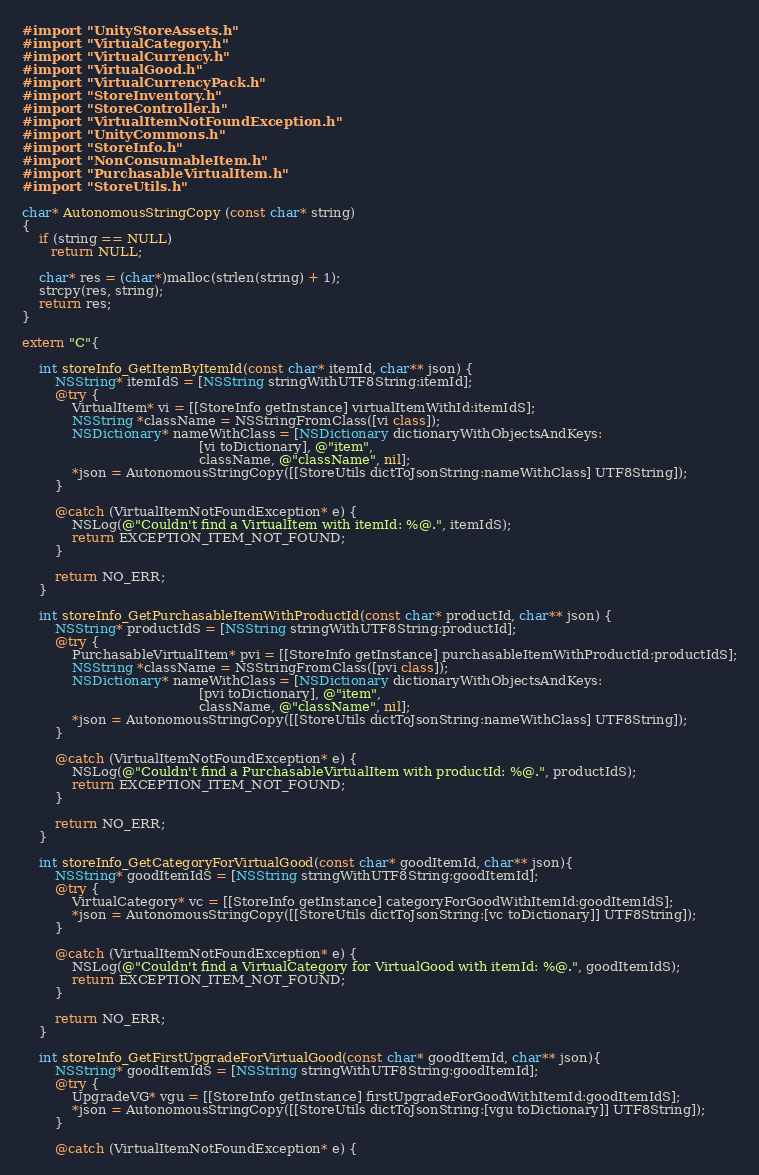<code> <loc_0><loc_0><loc_500><loc_500><_ObjectiveC_>#import "UnityStoreAssets.h"
#import "VirtualCategory.h"
#import "VirtualCurrency.h"
#import "VirtualGood.h"
#import "VirtualCurrencyPack.h"
#import "StoreInventory.h"
#import "StoreController.h"
#import "VirtualItemNotFoundException.h"
#import "UnityCommons.h"
#import "StoreInfo.h"
#import "NonConsumableItem.h"
#import "PurchasableVirtualItem.h"
#import "StoreUtils.h"

char* AutonomousStringCopy (const char* string)
{
    if (string == NULL)
       return NULL;

    char* res = (char*)malloc(strlen(string) + 1);
    strcpy(res, string);
    return res;
}

extern "C"{
	
	int storeInfo_GetItemByItemId(const char* itemId, char** json) {
        NSString* itemIdS = [NSString stringWithUTF8String:itemId];
		@try {
			VirtualItem* vi = [[StoreInfo getInstance] virtualItemWithId:itemIdS];
			NSString *className = NSStringFromClass([vi class]);
		    NSDictionary* nameWithClass = [NSDictionary dictionaryWithObjectsAndKeys:
		                                   [vi toDictionary], @"item",
		                                   className, @"className", nil];
			*json = AutonomousStringCopy([[StoreUtils dictToJsonString:nameWithClass] UTF8String]);
		}
		
		@catch (VirtualItemNotFoundException* e) {
            NSLog(@"Couldn't find a VirtualItem with itemId: %@.", itemIdS);
			return EXCEPTION_ITEM_NOT_FOUND;
        }

		return NO_ERR;
	}
	
	int storeInfo_GetPurchasableItemWithProductId(const char* productId, char** json) {
        NSString* productIdS = [NSString stringWithUTF8String:productId];
		@try {
			PurchasableVirtualItem* pvi = [[StoreInfo getInstance] purchasableItemWithProductId:productIdS];
			NSString *className = NSStringFromClass([pvi class]);
		    NSDictionary* nameWithClass = [NSDictionary dictionaryWithObjectsAndKeys:
		                                   [pvi toDictionary], @"item",
		                                   className, @"className", nil];
			*json = AutonomousStringCopy([[StoreUtils dictToJsonString:nameWithClass] UTF8String]);
		}
		
		@catch (VirtualItemNotFoundException* e) {
            NSLog(@"Couldn't find a PurchasableVirtualItem with productId: %@.", productIdS);
			return EXCEPTION_ITEM_NOT_FOUND;
        }

		return NO_ERR;
	}
	
	int storeInfo_GetCategoryForVirtualGood(const char* goodItemId, char** json){
		NSString* goodItemIdS = [NSString stringWithUTF8String:goodItemId];
		@try {
			VirtualCategory* vc = [[StoreInfo getInstance] categoryForGoodWithItemId:goodItemIdS];
			*json = AutonomousStringCopy([[StoreUtils dictToJsonString:[vc toDictionary]] UTF8String]);
		}
		
		@catch (VirtualItemNotFoundException* e) {
            NSLog(@"Couldn't find a VirtualCategory for VirtualGood with itemId: %@.", goodItemIdS);
			return EXCEPTION_ITEM_NOT_FOUND;
        }

		return NO_ERR;
	}
	
	int storeInfo_GetFirstUpgradeForVirtualGood(const char* goodItemId, char** json){
		NSString* goodItemIdS = [NSString stringWithUTF8String:goodItemId];
		@try {
			UpgradeVG* vgu = [[StoreInfo getInstance] firstUpgradeForGoodWithItemId:goodItemIdS];
			*json = AutonomousStringCopy([[StoreUtils dictToJsonString:[vgu toDictionary]] UTF8String]);
		}
		
		@catch (VirtualItemNotFoundException* e) {</code> 